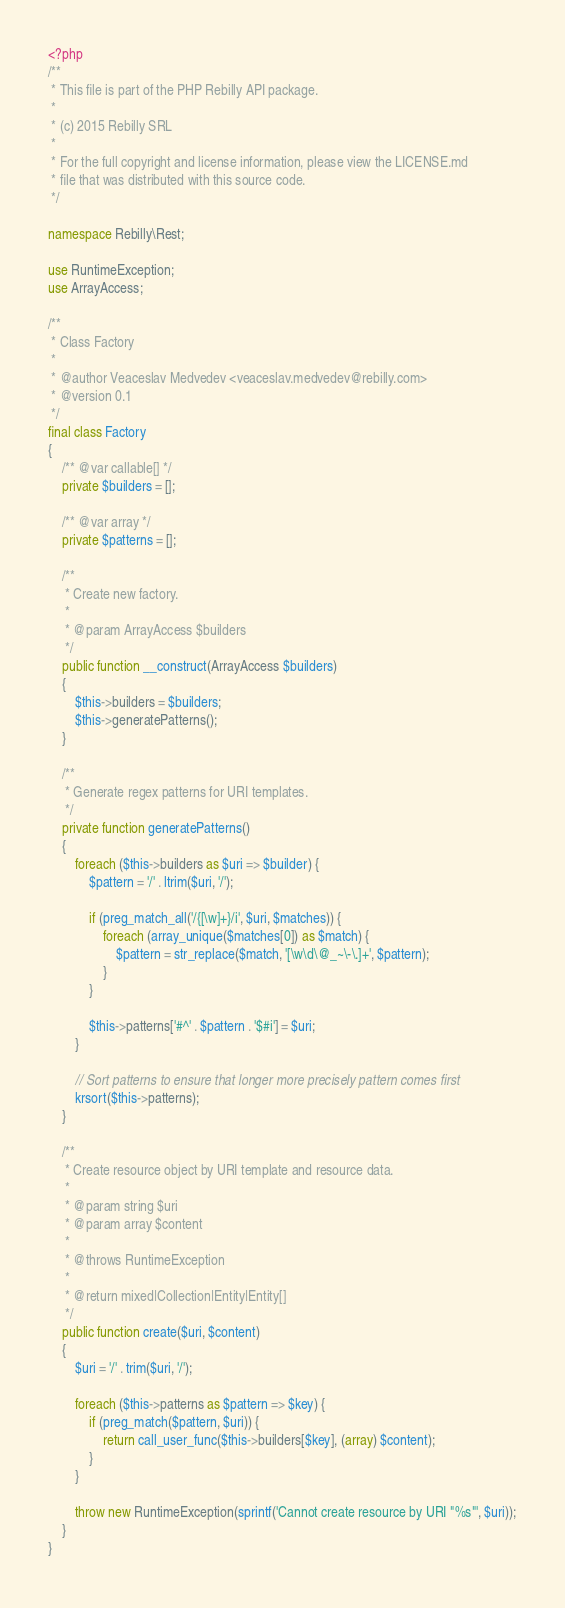Convert code to text. <code><loc_0><loc_0><loc_500><loc_500><_PHP_><?php
/**
 * This file is part of the PHP Rebilly API package.
 *
 * (c) 2015 Rebilly SRL
 *
 * For the full copyright and license information, please view the LICENSE.md
 * file that was distributed with this source code.
 */

namespace Rebilly\Rest;

use RuntimeException;
use ArrayAccess;

/**
 * Class Factory
 *
 * @author Veaceslav Medvedev <veaceslav.medvedev@rebilly.com>
 * @version 0.1
 */
final class Factory
{
    /** @var callable[] */
    private $builders = [];

    /** @var array */
    private $patterns = [];

    /**
     * Create new factory.
     *
     * @param ArrayAccess $builders
     */
    public function __construct(ArrayAccess $builders)
    {
        $this->builders = $builders;
        $this->generatePatterns();
    }

    /**
     * Generate regex patterns for URI templates.
     */
    private function generatePatterns()
    {
        foreach ($this->builders as $uri => $builder) {
            $pattern = '/' . ltrim($uri, '/');

            if (preg_match_all('/{[\w]+}/i', $uri, $matches)) {
                foreach (array_unique($matches[0]) as $match) {
                    $pattern = str_replace($match, '[\w\d\@_~\-\.]+', $pattern);
                }
            }

            $this->patterns['#^' . $pattern . '$#i'] = $uri;
        }

        // Sort patterns to ensure that longer more precisely pattern comes first
        krsort($this->patterns);
    }

    /**
     * Create resource object by URI template and resource data.
     *
     * @param string $uri
     * @param array $content
     *
     * @throws RuntimeException
     *
     * @return mixed|Collection|Entity|Entity[]
     */
    public function create($uri, $content)
    {
        $uri = '/' . trim($uri, '/');

        foreach ($this->patterns as $pattern => $key) {
            if (preg_match($pattern, $uri)) {
                return call_user_func($this->builders[$key], (array) $content);
            }
        }

        throw new RuntimeException(sprintf('Cannot create resource by URI "%s"', $uri));
    }
}
</code> 